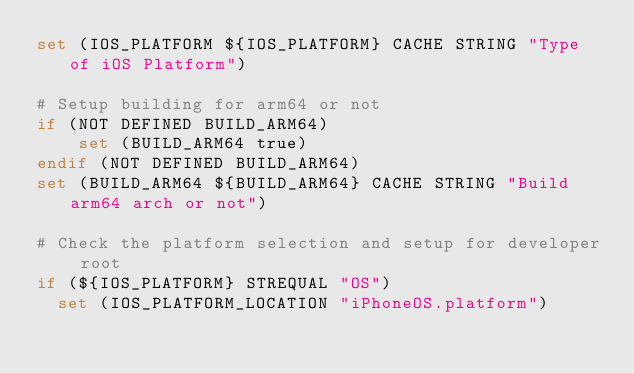<code> <loc_0><loc_0><loc_500><loc_500><_CMake_>set (IOS_PLATFORM ${IOS_PLATFORM} CACHE STRING "Type of iOS Platform")

# Setup building for arm64 or not
if (NOT DEFINED BUILD_ARM64)
    set (BUILD_ARM64 true)
endif (NOT DEFINED BUILD_ARM64)
set (BUILD_ARM64 ${BUILD_ARM64} CACHE STRING "Build arm64 arch or not")

# Check the platform selection and setup for developer root
if (${IOS_PLATFORM} STREQUAL "OS")
	set (IOS_PLATFORM_LOCATION "iPhoneOS.platform")
</code> 